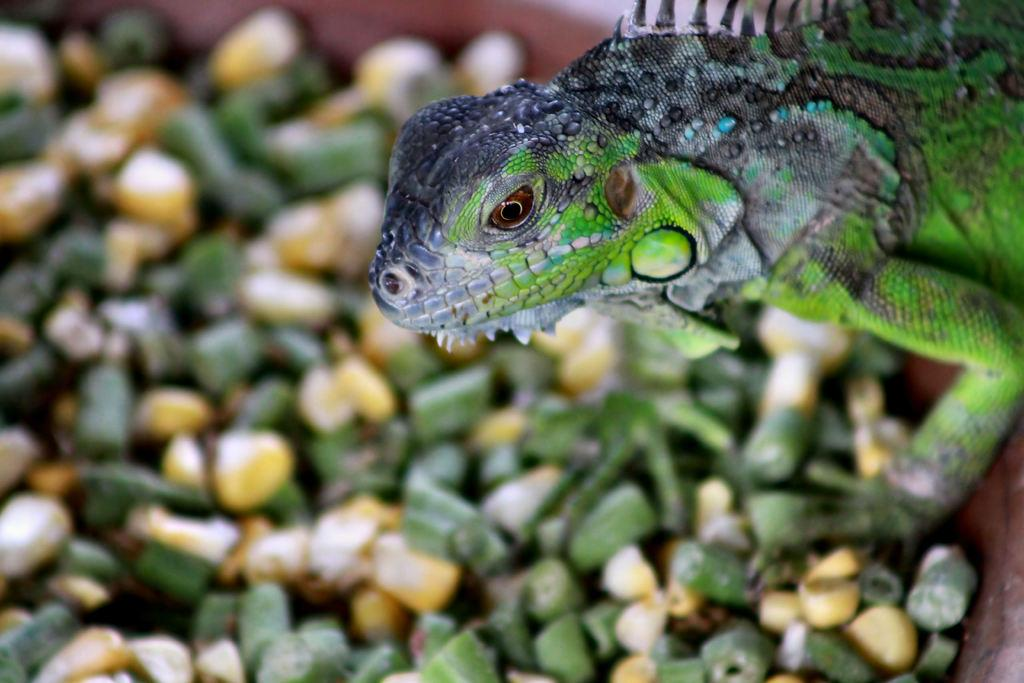What is the main subject of the image? The main subject of the image is a chameleon. What type of photography is used in the image? The image is a macro photography. How is the background of the image depicted? The background of the image is blurred. What type of action is the chameleon performing in the image? There is no specific action being performed by the chameleon in the image; it is simply sitting or resting. Can you see a rod in the image? There is no rod present in the image. 